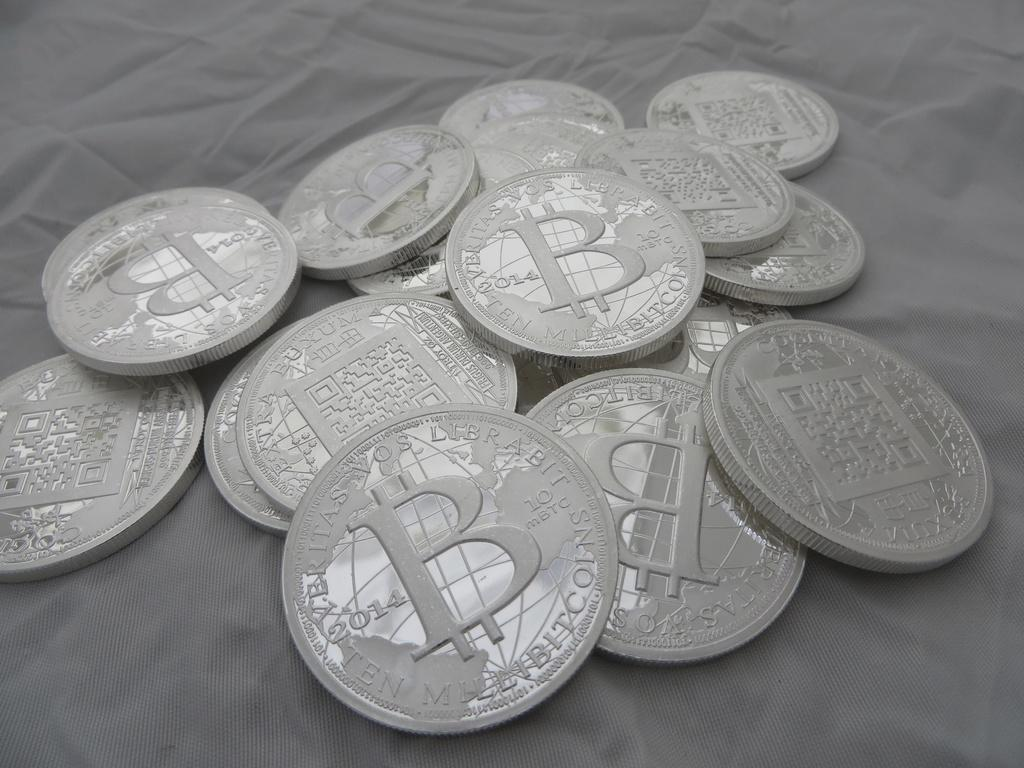What objects are in the image? There is a group of coins in the image. What is the coins placed on? The coins are placed on a cloth. What type of music can be heard playing in the background of the image? There is no music or sound present in the image, as it is a still image of coins placed on a cloth. Is there a rabbit visible in the image? No, there is no rabbit present in the image. 